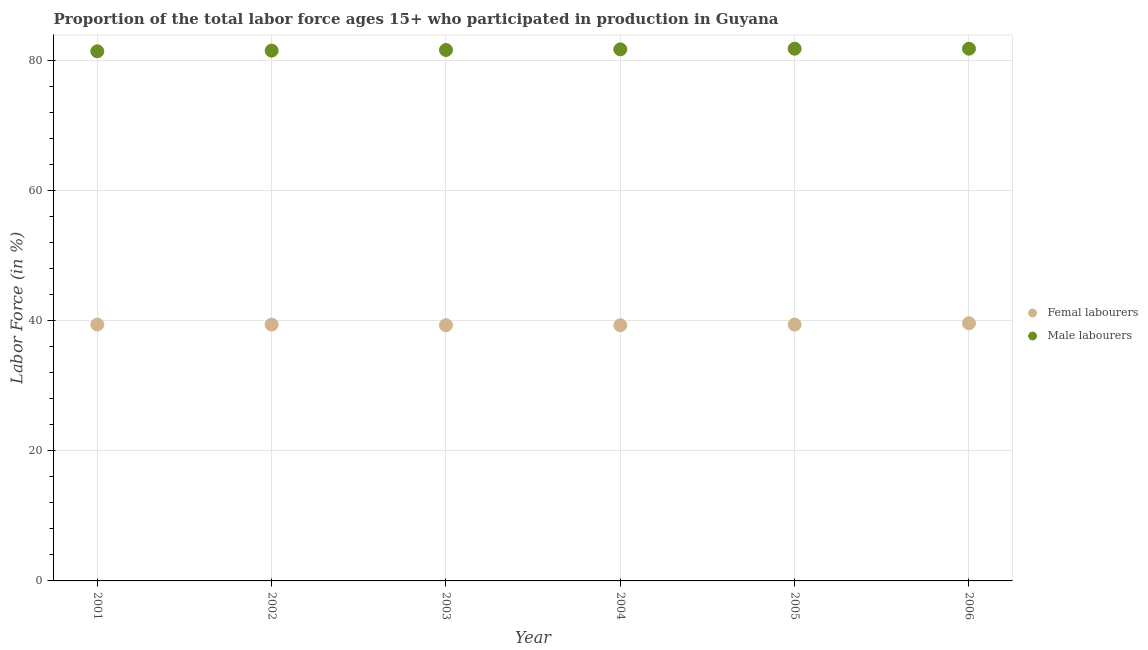How many different coloured dotlines are there?
Provide a short and direct response. 2. What is the percentage of male labour force in 2006?
Provide a succinct answer. 81.8. Across all years, what is the maximum percentage of female labor force?
Offer a very short reply. 39.6. Across all years, what is the minimum percentage of female labor force?
Make the answer very short. 39.3. In which year was the percentage of female labor force maximum?
Offer a terse response. 2006. In which year was the percentage of female labor force minimum?
Offer a very short reply. 2003. What is the total percentage of female labor force in the graph?
Make the answer very short. 236.4. What is the difference between the percentage of female labor force in 2004 and that in 2006?
Offer a very short reply. -0.3. What is the difference between the percentage of female labor force in 2006 and the percentage of male labour force in 2004?
Your answer should be compact. -42.1. What is the average percentage of female labor force per year?
Offer a very short reply. 39.4. In the year 2006, what is the difference between the percentage of female labor force and percentage of male labour force?
Keep it short and to the point. -42.2. In how many years, is the percentage of male labour force greater than 68 %?
Make the answer very short. 6. What is the ratio of the percentage of male labour force in 2001 to that in 2006?
Offer a terse response. 1. Is the percentage of female labor force in 2002 less than that in 2003?
Your response must be concise. No. What is the difference between the highest and the lowest percentage of male labour force?
Provide a short and direct response. 0.4. In how many years, is the percentage of female labor force greater than the average percentage of female labor force taken over all years?
Keep it short and to the point. 4. Is the percentage of male labour force strictly greater than the percentage of female labor force over the years?
Give a very brief answer. Yes. How many years are there in the graph?
Offer a terse response. 6. What is the difference between two consecutive major ticks on the Y-axis?
Your answer should be compact. 20. Does the graph contain grids?
Provide a succinct answer. Yes. Where does the legend appear in the graph?
Your answer should be compact. Center right. How many legend labels are there?
Provide a succinct answer. 2. What is the title of the graph?
Offer a very short reply. Proportion of the total labor force ages 15+ who participated in production in Guyana. What is the label or title of the X-axis?
Give a very brief answer. Year. What is the label or title of the Y-axis?
Keep it short and to the point. Labor Force (in %). What is the Labor Force (in %) in Femal labourers in 2001?
Offer a terse response. 39.4. What is the Labor Force (in %) of Male labourers in 2001?
Provide a short and direct response. 81.4. What is the Labor Force (in %) of Femal labourers in 2002?
Ensure brevity in your answer.  39.4. What is the Labor Force (in %) of Male labourers in 2002?
Make the answer very short. 81.5. What is the Labor Force (in %) of Femal labourers in 2003?
Your answer should be very brief. 39.3. What is the Labor Force (in %) in Male labourers in 2003?
Your answer should be very brief. 81.6. What is the Labor Force (in %) in Femal labourers in 2004?
Your answer should be very brief. 39.3. What is the Labor Force (in %) in Male labourers in 2004?
Keep it short and to the point. 81.7. What is the Labor Force (in %) in Femal labourers in 2005?
Give a very brief answer. 39.4. What is the Labor Force (in %) in Male labourers in 2005?
Your answer should be very brief. 81.8. What is the Labor Force (in %) in Femal labourers in 2006?
Your answer should be very brief. 39.6. What is the Labor Force (in %) of Male labourers in 2006?
Keep it short and to the point. 81.8. Across all years, what is the maximum Labor Force (in %) in Femal labourers?
Your answer should be very brief. 39.6. Across all years, what is the maximum Labor Force (in %) of Male labourers?
Provide a succinct answer. 81.8. Across all years, what is the minimum Labor Force (in %) of Femal labourers?
Offer a terse response. 39.3. Across all years, what is the minimum Labor Force (in %) of Male labourers?
Your answer should be compact. 81.4. What is the total Labor Force (in %) of Femal labourers in the graph?
Your response must be concise. 236.4. What is the total Labor Force (in %) in Male labourers in the graph?
Ensure brevity in your answer.  489.8. What is the difference between the Labor Force (in %) in Male labourers in 2001 and that in 2002?
Your answer should be very brief. -0.1. What is the difference between the Labor Force (in %) of Femal labourers in 2001 and that in 2003?
Offer a terse response. 0.1. What is the difference between the Labor Force (in %) of Male labourers in 2001 and that in 2003?
Offer a very short reply. -0.2. What is the difference between the Labor Force (in %) in Femal labourers in 2002 and that in 2003?
Provide a short and direct response. 0.1. What is the difference between the Labor Force (in %) of Femal labourers in 2002 and that in 2005?
Give a very brief answer. 0. What is the difference between the Labor Force (in %) of Male labourers in 2002 and that in 2006?
Your response must be concise. -0.3. What is the difference between the Labor Force (in %) in Femal labourers in 2003 and that in 2004?
Offer a terse response. 0. What is the difference between the Labor Force (in %) in Male labourers in 2003 and that in 2004?
Your answer should be compact. -0.1. What is the difference between the Labor Force (in %) in Femal labourers in 2003 and that in 2005?
Provide a short and direct response. -0.1. What is the difference between the Labor Force (in %) in Male labourers in 2003 and that in 2006?
Ensure brevity in your answer.  -0.2. What is the difference between the Labor Force (in %) of Femal labourers in 2004 and that in 2006?
Provide a short and direct response. -0.3. What is the difference between the Labor Force (in %) in Male labourers in 2004 and that in 2006?
Give a very brief answer. -0.1. What is the difference between the Labor Force (in %) of Male labourers in 2005 and that in 2006?
Your answer should be very brief. 0. What is the difference between the Labor Force (in %) in Femal labourers in 2001 and the Labor Force (in %) in Male labourers in 2002?
Give a very brief answer. -42.1. What is the difference between the Labor Force (in %) of Femal labourers in 2001 and the Labor Force (in %) of Male labourers in 2003?
Provide a succinct answer. -42.2. What is the difference between the Labor Force (in %) of Femal labourers in 2001 and the Labor Force (in %) of Male labourers in 2004?
Provide a succinct answer. -42.3. What is the difference between the Labor Force (in %) of Femal labourers in 2001 and the Labor Force (in %) of Male labourers in 2005?
Give a very brief answer. -42.4. What is the difference between the Labor Force (in %) of Femal labourers in 2001 and the Labor Force (in %) of Male labourers in 2006?
Your answer should be compact. -42.4. What is the difference between the Labor Force (in %) in Femal labourers in 2002 and the Labor Force (in %) in Male labourers in 2003?
Ensure brevity in your answer.  -42.2. What is the difference between the Labor Force (in %) in Femal labourers in 2002 and the Labor Force (in %) in Male labourers in 2004?
Provide a short and direct response. -42.3. What is the difference between the Labor Force (in %) in Femal labourers in 2002 and the Labor Force (in %) in Male labourers in 2005?
Provide a short and direct response. -42.4. What is the difference between the Labor Force (in %) of Femal labourers in 2002 and the Labor Force (in %) of Male labourers in 2006?
Offer a terse response. -42.4. What is the difference between the Labor Force (in %) in Femal labourers in 2003 and the Labor Force (in %) in Male labourers in 2004?
Your response must be concise. -42.4. What is the difference between the Labor Force (in %) of Femal labourers in 2003 and the Labor Force (in %) of Male labourers in 2005?
Offer a terse response. -42.5. What is the difference between the Labor Force (in %) in Femal labourers in 2003 and the Labor Force (in %) in Male labourers in 2006?
Offer a terse response. -42.5. What is the difference between the Labor Force (in %) in Femal labourers in 2004 and the Labor Force (in %) in Male labourers in 2005?
Provide a succinct answer. -42.5. What is the difference between the Labor Force (in %) in Femal labourers in 2004 and the Labor Force (in %) in Male labourers in 2006?
Provide a short and direct response. -42.5. What is the difference between the Labor Force (in %) of Femal labourers in 2005 and the Labor Force (in %) of Male labourers in 2006?
Make the answer very short. -42.4. What is the average Labor Force (in %) of Femal labourers per year?
Your answer should be very brief. 39.4. What is the average Labor Force (in %) of Male labourers per year?
Your answer should be very brief. 81.63. In the year 2001, what is the difference between the Labor Force (in %) of Femal labourers and Labor Force (in %) of Male labourers?
Offer a terse response. -42. In the year 2002, what is the difference between the Labor Force (in %) in Femal labourers and Labor Force (in %) in Male labourers?
Your answer should be very brief. -42.1. In the year 2003, what is the difference between the Labor Force (in %) in Femal labourers and Labor Force (in %) in Male labourers?
Ensure brevity in your answer.  -42.3. In the year 2004, what is the difference between the Labor Force (in %) in Femal labourers and Labor Force (in %) in Male labourers?
Give a very brief answer. -42.4. In the year 2005, what is the difference between the Labor Force (in %) of Femal labourers and Labor Force (in %) of Male labourers?
Offer a terse response. -42.4. In the year 2006, what is the difference between the Labor Force (in %) in Femal labourers and Labor Force (in %) in Male labourers?
Offer a very short reply. -42.2. What is the ratio of the Labor Force (in %) in Femal labourers in 2001 to that in 2002?
Your answer should be very brief. 1. What is the ratio of the Labor Force (in %) of Male labourers in 2001 to that in 2002?
Offer a terse response. 1. What is the ratio of the Labor Force (in %) in Male labourers in 2001 to that in 2003?
Make the answer very short. 1. What is the ratio of the Labor Force (in %) of Femal labourers in 2001 to that in 2004?
Provide a succinct answer. 1. What is the ratio of the Labor Force (in %) in Male labourers in 2001 to that in 2004?
Your response must be concise. 1. What is the ratio of the Labor Force (in %) of Femal labourers in 2001 to that in 2005?
Your answer should be very brief. 1. What is the ratio of the Labor Force (in %) in Femal labourers in 2001 to that in 2006?
Your answer should be compact. 0.99. What is the ratio of the Labor Force (in %) in Femal labourers in 2002 to that in 2003?
Provide a short and direct response. 1. What is the ratio of the Labor Force (in %) of Femal labourers in 2002 to that in 2004?
Your answer should be compact. 1. What is the ratio of the Labor Force (in %) in Male labourers in 2002 to that in 2004?
Keep it short and to the point. 1. What is the ratio of the Labor Force (in %) of Femal labourers in 2003 to that in 2004?
Your answer should be compact. 1. What is the ratio of the Labor Force (in %) in Male labourers in 2003 to that in 2004?
Offer a very short reply. 1. What is the ratio of the Labor Force (in %) of Femal labourers in 2003 to that in 2005?
Offer a terse response. 1. What is the ratio of the Labor Force (in %) of Femal labourers in 2003 to that in 2006?
Provide a succinct answer. 0.99. What is the ratio of the Labor Force (in %) in Male labourers in 2004 to that in 2005?
Ensure brevity in your answer.  1. What is the ratio of the Labor Force (in %) in Femal labourers in 2004 to that in 2006?
Provide a succinct answer. 0.99. What is the ratio of the Labor Force (in %) in Male labourers in 2004 to that in 2006?
Your answer should be very brief. 1. What is the difference between the highest and the second highest Labor Force (in %) of Femal labourers?
Give a very brief answer. 0.2. What is the difference between the highest and the second highest Labor Force (in %) of Male labourers?
Your response must be concise. 0. What is the difference between the highest and the lowest Labor Force (in %) in Male labourers?
Give a very brief answer. 0.4. 